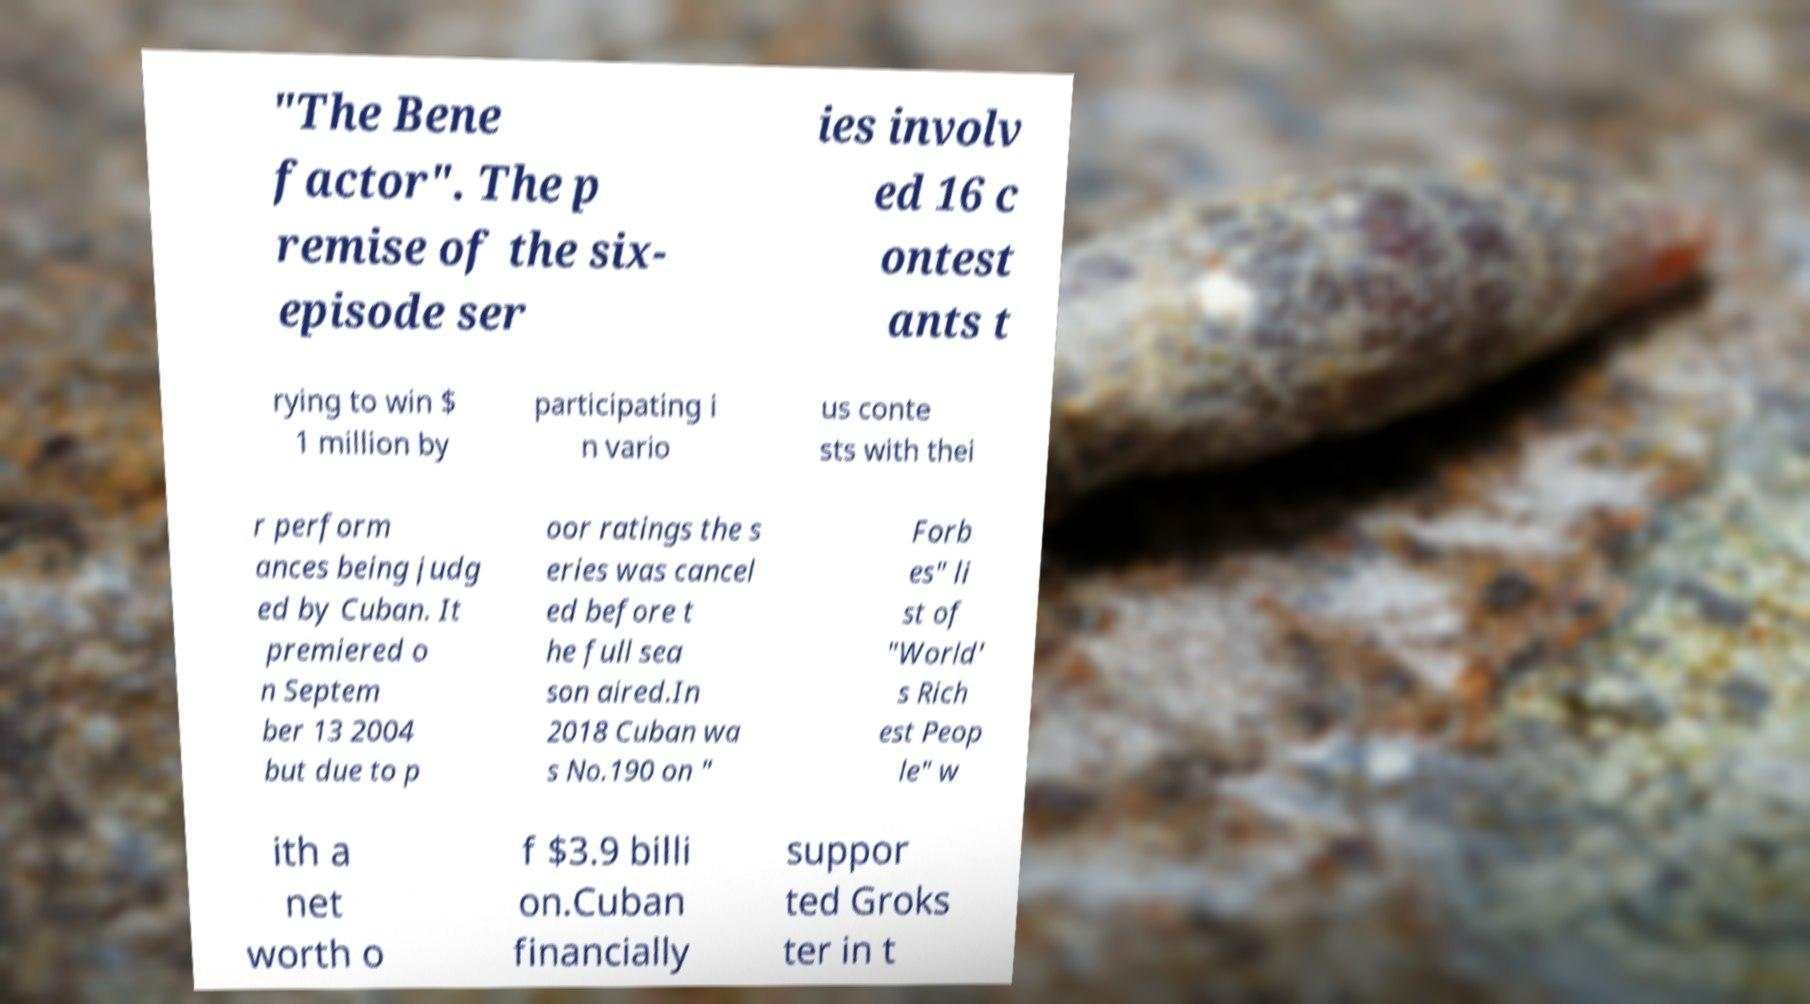Can you accurately transcribe the text from the provided image for me? "The Bene factor". The p remise of the six- episode ser ies involv ed 16 c ontest ants t rying to win $ 1 million by participating i n vario us conte sts with thei r perform ances being judg ed by Cuban. It premiered o n Septem ber 13 2004 but due to p oor ratings the s eries was cancel ed before t he full sea son aired.In 2018 Cuban wa s No.190 on " Forb es" li st of "World' s Rich est Peop le" w ith a net worth o f $3.9 billi on.Cuban financially suppor ted Groks ter in t 